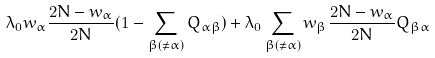<formula> <loc_0><loc_0><loc_500><loc_500>\lambda _ { 0 } w _ { \alpha } \frac { 2 N - w _ { \alpha } } { 2 N } ( 1 - \sum _ { \beta ( \neq \alpha ) } Q _ { \alpha \beta } ) + \lambda _ { 0 } \sum _ { \beta ( \neq \alpha ) } w _ { \beta } \frac { 2 N - w _ { \alpha } } { 2 N } Q _ { \beta \alpha }</formula> 